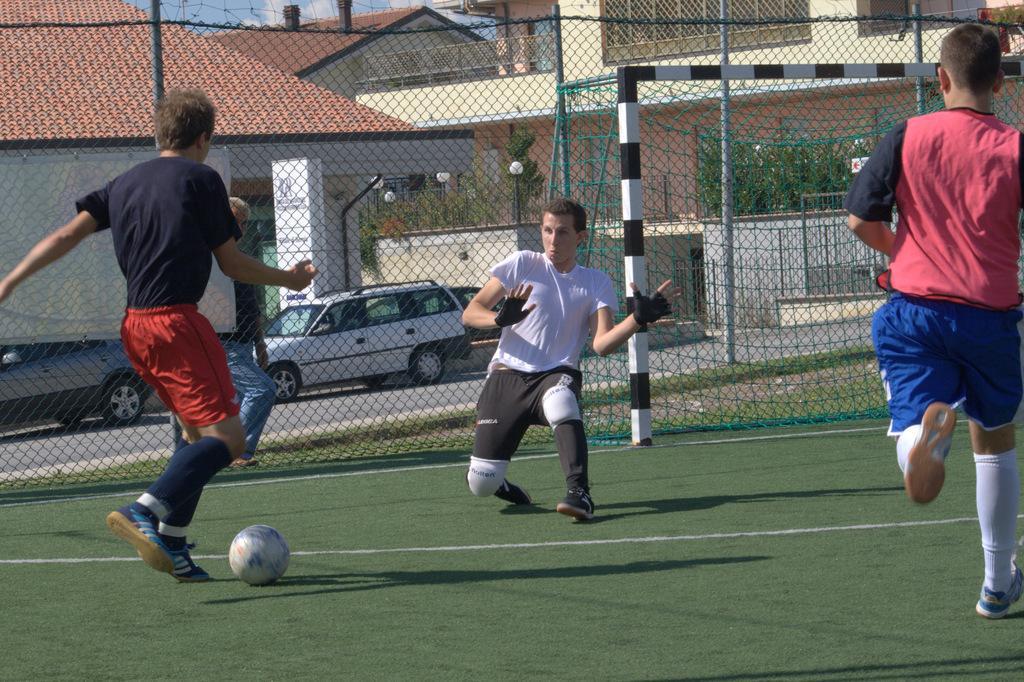How would you summarize this image in a sentence or two? This picture shows three players playing football and we see a metal fence and few houses on the back and couple of parked cars on the road. 